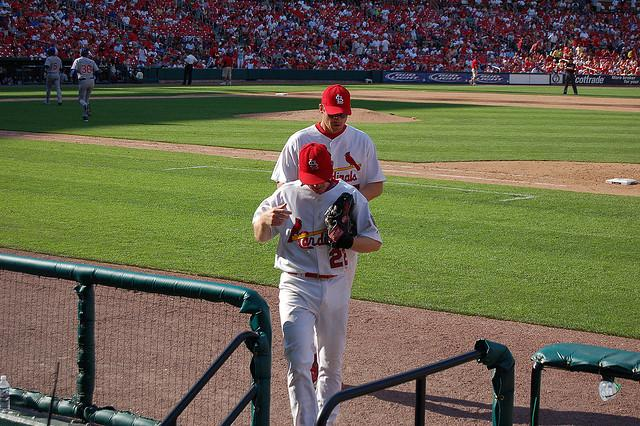At which location are the Cardinals playing?

Choices:
A) home field
B) wrigley
C) dodger stadium
D) shea home field 